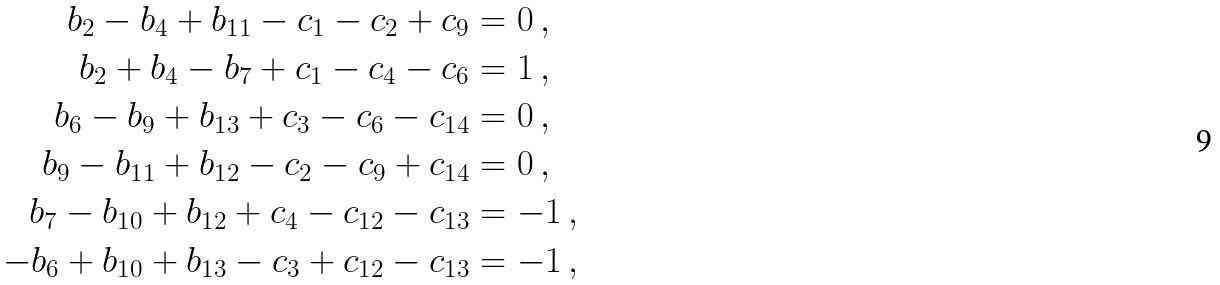Convert formula to latex. <formula><loc_0><loc_0><loc_500><loc_500>b _ { 2 } - b _ { 4 } + b _ { 1 1 } - c _ { 1 } - c _ { 2 } + c _ { 9 } & = 0 \, , \\ b _ { 2 } + b _ { 4 } - b _ { 7 } + c _ { 1 } - c _ { 4 } - c _ { 6 } & = 1 \, , \\ b _ { 6 } - b _ { 9 } + b _ { 1 3 } + c _ { 3 } - c _ { 6 } - c _ { 1 4 } & = 0 \, , \\ b _ { 9 } - b _ { 1 1 } + b _ { 1 2 } - c _ { 2 } - c _ { 9 } + c _ { 1 4 } & = 0 \, , \\ b _ { 7 } - b _ { 1 0 } + b _ { 1 2 } + c _ { 4 } - c _ { 1 2 } - c _ { 1 3 } & = - 1 \, , \\ - b _ { 6 } + b _ { 1 0 } + b _ { 1 3 } - c _ { 3 } + c _ { 1 2 } - c _ { 1 3 } & = - 1 \, ,</formula> 